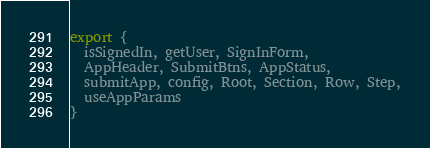Convert code to text. <code><loc_0><loc_0><loc_500><loc_500><_TypeScript_>

export {
  isSignedIn, getUser, SignInForm,
  AppHeader, SubmitBtns, AppStatus,
  submitApp, config, Root, Section, Row, Step,
  useAppParams
}</code> 